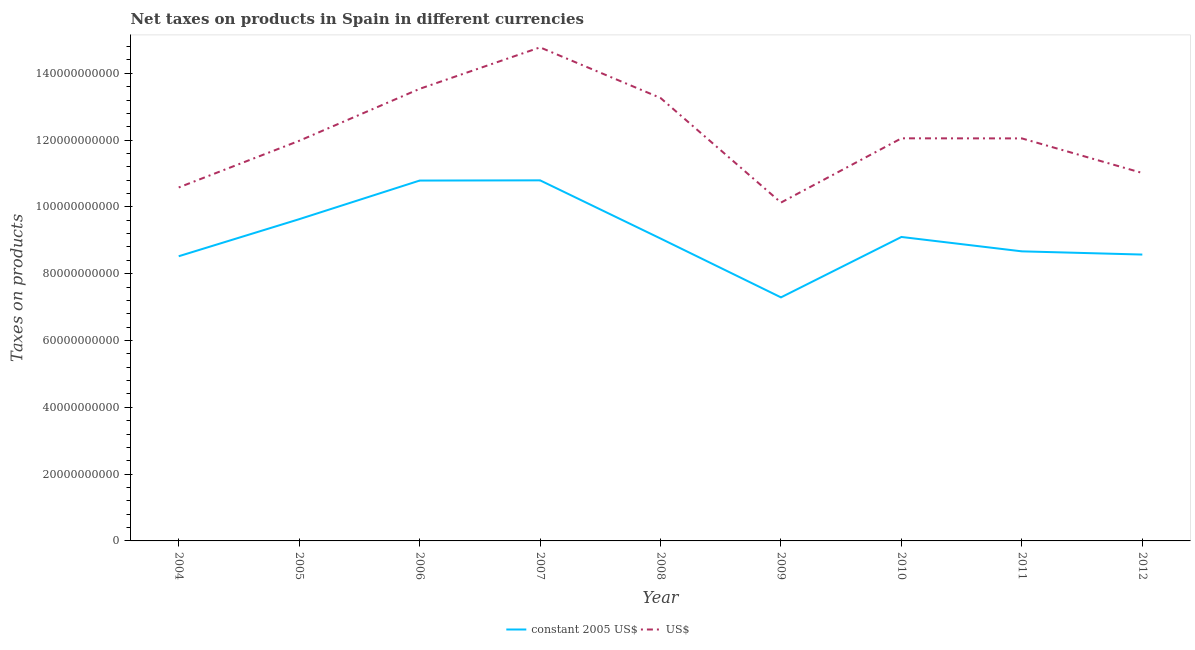Does the line corresponding to net taxes in us$ intersect with the line corresponding to net taxes in constant 2005 us$?
Your response must be concise. No. Is the number of lines equal to the number of legend labels?
Your answer should be compact. Yes. What is the net taxes in constant 2005 us$ in 2006?
Provide a succinct answer. 1.08e+11. Across all years, what is the maximum net taxes in us$?
Provide a short and direct response. 1.48e+11. Across all years, what is the minimum net taxes in constant 2005 us$?
Offer a very short reply. 7.29e+1. In which year was the net taxes in us$ maximum?
Your answer should be compact. 2007. What is the total net taxes in constant 2005 us$ in the graph?
Make the answer very short. 8.24e+11. What is the difference between the net taxes in us$ in 2005 and that in 2008?
Keep it short and to the point. -1.28e+1. What is the difference between the net taxes in constant 2005 us$ in 2011 and the net taxes in us$ in 2005?
Your answer should be very brief. -3.31e+1. What is the average net taxes in constant 2005 us$ per year?
Offer a terse response. 9.16e+1. In the year 2010, what is the difference between the net taxes in constant 2005 us$ and net taxes in us$?
Give a very brief answer. -2.95e+1. In how many years, is the net taxes in constant 2005 us$ greater than 124000000000 units?
Your response must be concise. 0. What is the ratio of the net taxes in us$ in 2008 to that in 2010?
Keep it short and to the point. 1.1. Is the net taxes in us$ in 2005 less than that in 2008?
Provide a short and direct response. Yes. Is the difference between the net taxes in constant 2005 us$ in 2004 and 2012 greater than the difference between the net taxes in us$ in 2004 and 2012?
Offer a very short reply. Yes. What is the difference between the highest and the second highest net taxes in us$?
Make the answer very short. 1.24e+1. What is the difference between the highest and the lowest net taxes in us$?
Give a very brief answer. 4.65e+1. Is the sum of the net taxes in us$ in 2004 and 2007 greater than the maximum net taxes in constant 2005 us$ across all years?
Keep it short and to the point. Yes. How many lines are there?
Provide a succinct answer. 2. How many years are there in the graph?
Offer a terse response. 9. What is the difference between two consecutive major ticks on the Y-axis?
Provide a short and direct response. 2.00e+1. Does the graph contain any zero values?
Keep it short and to the point. No. Does the graph contain grids?
Provide a succinct answer. No. Where does the legend appear in the graph?
Your answer should be compact. Bottom center. How many legend labels are there?
Your response must be concise. 2. What is the title of the graph?
Your response must be concise. Net taxes on products in Spain in different currencies. What is the label or title of the X-axis?
Make the answer very short. Year. What is the label or title of the Y-axis?
Give a very brief answer. Taxes on products. What is the Taxes on products in constant 2005 US$ in 2004?
Provide a short and direct response. 8.52e+1. What is the Taxes on products of US$ in 2004?
Ensure brevity in your answer.  1.06e+11. What is the Taxes on products of constant 2005 US$ in 2005?
Ensure brevity in your answer.  9.63e+1. What is the Taxes on products of US$ in 2005?
Give a very brief answer. 1.20e+11. What is the Taxes on products in constant 2005 US$ in 2006?
Keep it short and to the point. 1.08e+11. What is the Taxes on products in US$ in 2006?
Keep it short and to the point. 1.35e+11. What is the Taxes on products of constant 2005 US$ in 2007?
Give a very brief answer. 1.08e+11. What is the Taxes on products of US$ in 2007?
Make the answer very short. 1.48e+11. What is the Taxes on products in constant 2005 US$ in 2008?
Provide a short and direct response. 9.05e+1. What is the Taxes on products in US$ in 2008?
Your answer should be very brief. 1.33e+11. What is the Taxes on products of constant 2005 US$ in 2009?
Provide a succinct answer. 7.29e+1. What is the Taxes on products of US$ in 2009?
Provide a succinct answer. 1.01e+11. What is the Taxes on products of constant 2005 US$ in 2010?
Make the answer very short. 9.10e+1. What is the Taxes on products in US$ in 2010?
Ensure brevity in your answer.  1.21e+11. What is the Taxes on products in constant 2005 US$ in 2011?
Offer a very short reply. 8.67e+1. What is the Taxes on products in US$ in 2011?
Keep it short and to the point. 1.21e+11. What is the Taxes on products in constant 2005 US$ in 2012?
Your answer should be compact. 8.57e+1. What is the Taxes on products in US$ in 2012?
Provide a succinct answer. 1.10e+11. Across all years, what is the maximum Taxes on products in constant 2005 US$?
Offer a terse response. 1.08e+11. Across all years, what is the maximum Taxes on products in US$?
Ensure brevity in your answer.  1.48e+11. Across all years, what is the minimum Taxes on products of constant 2005 US$?
Keep it short and to the point. 7.29e+1. Across all years, what is the minimum Taxes on products of US$?
Provide a short and direct response. 1.01e+11. What is the total Taxes on products in constant 2005 US$ in the graph?
Your response must be concise. 8.24e+11. What is the total Taxes on products in US$ in the graph?
Provide a short and direct response. 1.09e+12. What is the difference between the Taxes on products of constant 2005 US$ in 2004 and that in 2005?
Keep it short and to the point. -1.11e+1. What is the difference between the Taxes on products of US$ in 2004 and that in 2005?
Provide a short and direct response. -1.40e+1. What is the difference between the Taxes on products of constant 2005 US$ in 2004 and that in 2006?
Give a very brief answer. -2.27e+1. What is the difference between the Taxes on products of US$ in 2004 and that in 2006?
Your answer should be very brief. -2.95e+1. What is the difference between the Taxes on products of constant 2005 US$ in 2004 and that in 2007?
Ensure brevity in your answer.  -2.27e+1. What is the difference between the Taxes on products in US$ in 2004 and that in 2007?
Provide a succinct answer. -4.19e+1. What is the difference between the Taxes on products in constant 2005 US$ in 2004 and that in 2008?
Your answer should be compact. -5.31e+09. What is the difference between the Taxes on products of US$ in 2004 and that in 2008?
Your answer should be compact. -2.68e+1. What is the difference between the Taxes on products of constant 2005 US$ in 2004 and that in 2009?
Ensure brevity in your answer.  1.23e+1. What is the difference between the Taxes on products of US$ in 2004 and that in 2009?
Make the answer very short. 4.52e+09. What is the difference between the Taxes on products in constant 2005 US$ in 2004 and that in 2010?
Your response must be concise. -5.77e+09. What is the difference between the Taxes on products of US$ in 2004 and that in 2010?
Keep it short and to the point. -1.47e+1. What is the difference between the Taxes on products of constant 2005 US$ in 2004 and that in 2011?
Give a very brief answer. -1.46e+09. What is the difference between the Taxes on products in US$ in 2004 and that in 2011?
Your answer should be very brief. -1.47e+1. What is the difference between the Taxes on products in constant 2005 US$ in 2004 and that in 2012?
Offer a terse response. -5.05e+08. What is the difference between the Taxes on products in US$ in 2004 and that in 2012?
Offer a very short reply. -4.33e+09. What is the difference between the Taxes on products of constant 2005 US$ in 2005 and that in 2006?
Your response must be concise. -1.16e+1. What is the difference between the Taxes on products in US$ in 2005 and that in 2006?
Provide a short and direct response. -1.56e+1. What is the difference between the Taxes on products in constant 2005 US$ in 2005 and that in 2007?
Keep it short and to the point. -1.16e+1. What is the difference between the Taxes on products of US$ in 2005 and that in 2007?
Your response must be concise. -2.80e+1. What is the difference between the Taxes on products of constant 2005 US$ in 2005 and that in 2008?
Make the answer very short. 5.78e+09. What is the difference between the Taxes on products in US$ in 2005 and that in 2008?
Offer a terse response. -1.28e+1. What is the difference between the Taxes on products of constant 2005 US$ in 2005 and that in 2009?
Keep it short and to the point. 2.34e+1. What is the difference between the Taxes on products of US$ in 2005 and that in 2009?
Your answer should be compact. 1.85e+1. What is the difference between the Taxes on products of constant 2005 US$ in 2005 and that in 2010?
Offer a terse response. 5.32e+09. What is the difference between the Taxes on products in US$ in 2005 and that in 2010?
Ensure brevity in your answer.  -7.45e+08. What is the difference between the Taxes on products of constant 2005 US$ in 2005 and that in 2011?
Make the answer very short. 9.63e+09. What is the difference between the Taxes on products of US$ in 2005 and that in 2011?
Give a very brief answer. -7.21e+08. What is the difference between the Taxes on products of constant 2005 US$ in 2005 and that in 2012?
Make the answer very short. 1.06e+1. What is the difference between the Taxes on products in US$ in 2005 and that in 2012?
Ensure brevity in your answer.  9.63e+09. What is the difference between the Taxes on products of constant 2005 US$ in 2006 and that in 2007?
Your response must be concise. -7.00e+07. What is the difference between the Taxes on products of US$ in 2006 and that in 2007?
Give a very brief answer. -1.24e+1. What is the difference between the Taxes on products in constant 2005 US$ in 2006 and that in 2008?
Offer a very short reply. 1.73e+1. What is the difference between the Taxes on products in US$ in 2006 and that in 2008?
Your answer should be very brief. 2.73e+09. What is the difference between the Taxes on products in constant 2005 US$ in 2006 and that in 2009?
Your answer should be very brief. 3.50e+1. What is the difference between the Taxes on products of US$ in 2006 and that in 2009?
Your answer should be very brief. 3.40e+1. What is the difference between the Taxes on products in constant 2005 US$ in 2006 and that in 2010?
Offer a terse response. 1.69e+1. What is the difference between the Taxes on products of US$ in 2006 and that in 2010?
Your answer should be very brief. 1.48e+1. What is the difference between the Taxes on products in constant 2005 US$ in 2006 and that in 2011?
Keep it short and to the point. 2.12e+1. What is the difference between the Taxes on products of US$ in 2006 and that in 2011?
Offer a terse response. 1.48e+1. What is the difference between the Taxes on products of constant 2005 US$ in 2006 and that in 2012?
Keep it short and to the point. 2.22e+1. What is the difference between the Taxes on products in US$ in 2006 and that in 2012?
Your response must be concise. 2.52e+1. What is the difference between the Taxes on products of constant 2005 US$ in 2007 and that in 2008?
Give a very brief answer. 1.74e+1. What is the difference between the Taxes on products in US$ in 2007 and that in 2008?
Give a very brief answer. 1.51e+1. What is the difference between the Taxes on products of constant 2005 US$ in 2007 and that in 2009?
Offer a very short reply. 3.50e+1. What is the difference between the Taxes on products in US$ in 2007 and that in 2009?
Offer a terse response. 4.65e+1. What is the difference between the Taxes on products in constant 2005 US$ in 2007 and that in 2010?
Your answer should be compact. 1.70e+1. What is the difference between the Taxes on products in US$ in 2007 and that in 2010?
Your answer should be very brief. 2.72e+1. What is the difference between the Taxes on products in constant 2005 US$ in 2007 and that in 2011?
Your answer should be compact. 2.13e+1. What is the difference between the Taxes on products of US$ in 2007 and that in 2011?
Make the answer very short. 2.73e+1. What is the difference between the Taxes on products in constant 2005 US$ in 2007 and that in 2012?
Your response must be concise. 2.22e+1. What is the difference between the Taxes on products in US$ in 2007 and that in 2012?
Your answer should be compact. 3.76e+1. What is the difference between the Taxes on products of constant 2005 US$ in 2008 and that in 2009?
Offer a very short reply. 1.76e+1. What is the difference between the Taxes on products of US$ in 2008 and that in 2009?
Your answer should be very brief. 3.13e+1. What is the difference between the Taxes on products of constant 2005 US$ in 2008 and that in 2010?
Your answer should be compact. -4.65e+08. What is the difference between the Taxes on products of US$ in 2008 and that in 2010?
Ensure brevity in your answer.  1.21e+1. What is the difference between the Taxes on products of constant 2005 US$ in 2008 and that in 2011?
Give a very brief answer. 3.84e+09. What is the difference between the Taxes on products of US$ in 2008 and that in 2011?
Make the answer very short. 1.21e+1. What is the difference between the Taxes on products of constant 2005 US$ in 2008 and that in 2012?
Your answer should be compact. 4.80e+09. What is the difference between the Taxes on products of US$ in 2008 and that in 2012?
Your answer should be compact. 2.25e+1. What is the difference between the Taxes on products of constant 2005 US$ in 2009 and that in 2010?
Your answer should be compact. -1.81e+1. What is the difference between the Taxes on products of US$ in 2009 and that in 2010?
Your response must be concise. -1.92e+1. What is the difference between the Taxes on products in constant 2005 US$ in 2009 and that in 2011?
Your response must be concise. -1.38e+1. What is the difference between the Taxes on products of US$ in 2009 and that in 2011?
Give a very brief answer. -1.92e+1. What is the difference between the Taxes on products in constant 2005 US$ in 2009 and that in 2012?
Provide a short and direct response. -1.28e+1. What is the difference between the Taxes on products of US$ in 2009 and that in 2012?
Make the answer very short. -8.86e+09. What is the difference between the Taxes on products of constant 2005 US$ in 2010 and that in 2011?
Your answer should be compact. 4.31e+09. What is the difference between the Taxes on products of US$ in 2010 and that in 2011?
Your answer should be compact. 2.38e+07. What is the difference between the Taxes on products of constant 2005 US$ in 2010 and that in 2012?
Offer a very short reply. 5.27e+09. What is the difference between the Taxes on products of US$ in 2010 and that in 2012?
Ensure brevity in your answer.  1.04e+1. What is the difference between the Taxes on products in constant 2005 US$ in 2011 and that in 2012?
Give a very brief answer. 9.60e+08. What is the difference between the Taxes on products of US$ in 2011 and that in 2012?
Your answer should be very brief. 1.04e+1. What is the difference between the Taxes on products of constant 2005 US$ in 2004 and the Taxes on products of US$ in 2005?
Your response must be concise. -3.46e+1. What is the difference between the Taxes on products of constant 2005 US$ in 2004 and the Taxes on products of US$ in 2006?
Ensure brevity in your answer.  -5.01e+1. What is the difference between the Taxes on products of constant 2005 US$ in 2004 and the Taxes on products of US$ in 2007?
Your answer should be very brief. -6.25e+1. What is the difference between the Taxes on products in constant 2005 US$ in 2004 and the Taxes on products in US$ in 2008?
Your answer should be compact. -4.74e+1. What is the difference between the Taxes on products in constant 2005 US$ in 2004 and the Taxes on products in US$ in 2009?
Your answer should be compact. -1.61e+1. What is the difference between the Taxes on products in constant 2005 US$ in 2004 and the Taxes on products in US$ in 2010?
Provide a succinct answer. -3.53e+1. What is the difference between the Taxes on products in constant 2005 US$ in 2004 and the Taxes on products in US$ in 2011?
Your response must be concise. -3.53e+1. What is the difference between the Taxes on products in constant 2005 US$ in 2004 and the Taxes on products in US$ in 2012?
Your response must be concise. -2.49e+1. What is the difference between the Taxes on products in constant 2005 US$ in 2005 and the Taxes on products in US$ in 2006?
Make the answer very short. -3.90e+1. What is the difference between the Taxes on products of constant 2005 US$ in 2005 and the Taxes on products of US$ in 2007?
Offer a terse response. -5.14e+1. What is the difference between the Taxes on products in constant 2005 US$ in 2005 and the Taxes on products in US$ in 2008?
Make the answer very short. -3.63e+1. What is the difference between the Taxes on products of constant 2005 US$ in 2005 and the Taxes on products of US$ in 2009?
Keep it short and to the point. -4.98e+09. What is the difference between the Taxes on products in constant 2005 US$ in 2005 and the Taxes on products in US$ in 2010?
Keep it short and to the point. -2.42e+1. What is the difference between the Taxes on products of constant 2005 US$ in 2005 and the Taxes on products of US$ in 2011?
Your response must be concise. -2.42e+1. What is the difference between the Taxes on products of constant 2005 US$ in 2005 and the Taxes on products of US$ in 2012?
Make the answer very short. -1.38e+1. What is the difference between the Taxes on products in constant 2005 US$ in 2006 and the Taxes on products in US$ in 2007?
Offer a very short reply. -3.99e+1. What is the difference between the Taxes on products of constant 2005 US$ in 2006 and the Taxes on products of US$ in 2008?
Give a very brief answer. -2.47e+1. What is the difference between the Taxes on products in constant 2005 US$ in 2006 and the Taxes on products in US$ in 2009?
Offer a terse response. 6.59e+09. What is the difference between the Taxes on products in constant 2005 US$ in 2006 and the Taxes on products in US$ in 2010?
Provide a succinct answer. -1.26e+1. What is the difference between the Taxes on products in constant 2005 US$ in 2006 and the Taxes on products in US$ in 2011?
Your answer should be very brief. -1.26e+1. What is the difference between the Taxes on products in constant 2005 US$ in 2006 and the Taxes on products in US$ in 2012?
Ensure brevity in your answer.  -2.27e+09. What is the difference between the Taxes on products in constant 2005 US$ in 2007 and the Taxes on products in US$ in 2008?
Your response must be concise. -2.47e+1. What is the difference between the Taxes on products in constant 2005 US$ in 2007 and the Taxes on products in US$ in 2009?
Offer a very short reply. 6.66e+09. What is the difference between the Taxes on products in constant 2005 US$ in 2007 and the Taxes on products in US$ in 2010?
Offer a terse response. -1.26e+1. What is the difference between the Taxes on products of constant 2005 US$ in 2007 and the Taxes on products of US$ in 2011?
Give a very brief answer. -1.26e+1. What is the difference between the Taxes on products of constant 2005 US$ in 2007 and the Taxes on products of US$ in 2012?
Your answer should be very brief. -2.20e+09. What is the difference between the Taxes on products in constant 2005 US$ in 2008 and the Taxes on products in US$ in 2009?
Make the answer very short. -1.08e+1. What is the difference between the Taxes on products of constant 2005 US$ in 2008 and the Taxes on products of US$ in 2010?
Make the answer very short. -3.00e+1. What is the difference between the Taxes on products of constant 2005 US$ in 2008 and the Taxes on products of US$ in 2011?
Provide a succinct answer. -3.00e+1. What is the difference between the Taxes on products of constant 2005 US$ in 2008 and the Taxes on products of US$ in 2012?
Your answer should be very brief. -1.96e+1. What is the difference between the Taxes on products in constant 2005 US$ in 2009 and the Taxes on products in US$ in 2010?
Offer a terse response. -4.76e+1. What is the difference between the Taxes on products in constant 2005 US$ in 2009 and the Taxes on products in US$ in 2011?
Offer a terse response. -4.76e+1. What is the difference between the Taxes on products of constant 2005 US$ in 2009 and the Taxes on products of US$ in 2012?
Provide a short and direct response. -3.72e+1. What is the difference between the Taxes on products of constant 2005 US$ in 2010 and the Taxes on products of US$ in 2011?
Offer a terse response. -2.95e+1. What is the difference between the Taxes on products of constant 2005 US$ in 2010 and the Taxes on products of US$ in 2012?
Ensure brevity in your answer.  -1.92e+1. What is the difference between the Taxes on products in constant 2005 US$ in 2011 and the Taxes on products in US$ in 2012?
Provide a succinct answer. -2.35e+1. What is the average Taxes on products of constant 2005 US$ per year?
Provide a short and direct response. 9.16e+1. What is the average Taxes on products in US$ per year?
Your answer should be compact. 1.22e+11. In the year 2004, what is the difference between the Taxes on products in constant 2005 US$ and Taxes on products in US$?
Provide a succinct answer. -2.06e+1. In the year 2005, what is the difference between the Taxes on products in constant 2005 US$ and Taxes on products in US$?
Your answer should be compact. -2.35e+1. In the year 2006, what is the difference between the Taxes on products in constant 2005 US$ and Taxes on products in US$?
Your answer should be compact. -2.75e+1. In the year 2007, what is the difference between the Taxes on products of constant 2005 US$ and Taxes on products of US$?
Make the answer very short. -3.98e+1. In the year 2008, what is the difference between the Taxes on products in constant 2005 US$ and Taxes on products in US$?
Your answer should be very brief. -4.21e+1. In the year 2009, what is the difference between the Taxes on products of constant 2005 US$ and Taxes on products of US$?
Your response must be concise. -2.84e+1. In the year 2010, what is the difference between the Taxes on products in constant 2005 US$ and Taxes on products in US$?
Your answer should be compact. -2.95e+1. In the year 2011, what is the difference between the Taxes on products in constant 2005 US$ and Taxes on products in US$?
Your response must be concise. -3.38e+1. In the year 2012, what is the difference between the Taxes on products in constant 2005 US$ and Taxes on products in US$?
Offer a terse response. -2.44e+1. What is the ratio of the Taxes on products in constant 2005 US$ in 2004 to that in 2005?
Give a very brief answer. 0.88. What is the ratio of the Taxes on products in US$ in 2004 to that in 2005?
Offer a terse response. 0.88. What is the ratio of the Taxes on products in constant 2005 US$ in 2004 to that in 2006?
Your answer should be compact. 0.79. What is the ratio of the Taxes on products in US$ in 2004 to that in 2006?
Your response must be concise. 0.78. What is the ratio of the Taxes on products in constant 2005 US$ in 2004 to that in 2007?
Your response must be concise. 0.79. What is the ratio of the Taxes on products in US$ in 2004 to that in 2007?
Provide a short and direct response. 0.72. What is the ratio of the Taxes on products in constant 2005 US$ in 2004 to that in 2008?
Your answer should be very brief. 0.94. What is the ratio of the Taxes on products in US$ in 2004 to that in 2008?
Offer a terse response. 0.8. What is the ratio of the Taxes on products in constant 2005 US$ in 2004 to that in 2009?
Offer a very short reply. 1.17. What is the ratio of the Taxes on products of US$ in 2004 to that in 2009?
Make the answer very short. 1.04. What is the ratio of the Taxes on products of constant 2005 US$ in 2004 to that in 2010?
Offer a very short reply. 0.94. What is the ratio of the Taxes on products of US$ in 2004 to that in 2010?
Ensure brevity in your answer.  0.88. What is the ratio of the Taxes on products in constant 2005 US$ in 2004 to that in 2011?
Provide a succinct answer. 0.98. What is the ratio of the Taxes on products in US$ in 2004 to that in 2011?
Offer a very short reply. 0.88. What is the ratio of the Taxes on products of constant 2005 US$ in 2004 to that in 2012?
Offer a very short reply. 0.99. What is the ratio of the Taxes on products of US$ in 2004 to that in 2012?
Give a very brief answer. 0.96. What is the ratio of the Taxes on products in constant 2005 US$ in 2005 to that in 2006?
Offer a very short reply. 0.89. What is the ratio of the Taxes on products of US$ in 2005 to that in 2006?
Keep it short and to the point. 0.89. What is the ratio of the Taxes on products in constant 2005 US$ in 2005 to that in 2007?
Ensure brevity in your answer.  0.89. What is the ratio of the Taxes on products of US$ in 2005 to that in 2007?
Make the answer very short. 0.81. What is the ratio of the Taxes on products in constant 2005 US$ in 2005 to that in 2008?
Offer a very short reply. 1.06. What is the ratio of the Taxes on products in US$ in 2005 to that in 2008?
Your response must be concise. 0.9. What is the ratio of the Taxes on products of constant 2005 US$ in 2005 to that in 2009?
Your answer should be very brief. 1.32. What is the ratio of the Taxes on products in US$ in 2005 to that in 2009?
Your response must be concise. 1.18. What is the ratio of the Taxes on products in constant 2005 US$ in 2005 to that in 2010?
Ensure brevity in your answer.  1.06. What is the ratio of the Taxes on products in constant 2005 US$ in 2005 to that in 2011?
Your answer should be very brief. 1.11. What is the ratio of the Taxes on products in US$ in 2005 to that in 2011?
Your response must be concise. 0.99. What is the ratio of the Taxes on products in constant 2005 US$ in 2005 to that in 2012?
Your answer should be very brief. 1.12. What is the ratio of the Taxes on products of US$ in 2005 to that in 2012?
Offer a terse response. 1.09. What is the ratio of the Taxes on products of constant 2005 US$ in 2006 to that in 2007?
Your answer should be compact. 1. What is the ratio of the Taxes on products of US$ in 2006 to that in 2007?
Give a very brief answer. 0.92. What is the ratio of the Taxes on products of constant 2005 US$ in 2006 to that in 2008?
Your answer should be very brief. 1.19. What is the ratio of the Taxes on products in US$ in 2006 to that in 2008?
Make the answer very short. 1.02. What is the ratio of the Taxes on products in constant 2005 US$ in 2006 to that in 2009?
Offer a terse response. 1.48. What is the ratio of the Taxes on products of US$ in 2006 to that in 2009?
Keep it short and to the point. 1.34. What is the ratio of the Taxes on products in constant 2005 US$ in 2006 to that in 2010?
Keep it short and to the point. 1.19. What is the ratio of the Taxes on products of US$ in 2006 to that in 2010?
Your response must be concise. 1.12. What is the ratio of the Taxes on products of constant 2005 US$ in 2006 to that in 2011?
Your response must be concise. 1.24. What is the ratio of the Taxes on products in US$ in 2006 to that in 2011?
Ensure brevity in your answer.  1.12. What is the ratio of the Taxes on products of constant 2005 US$ in 2006 to that in 2012?
Keep it short and to the point. 1.26. What is the ratio of the Taxes on products in US$ in 2006 to that in 2012?
Give a very brief answer. 1.23. What is the ratio of the Taxes on products in constant 2005 US$ in 2007 to that in 2008?
Offer a terse response. 1.19. What is the ratio of the Taxes on products of US$ in 2007 to that in 2008?
Your response must be concise. 1.11. What is the ratio of the Taxes on products of constant 2005 US$ in 2007 to that in 2009?
Your response must be concise. 1.48. What is the ratio of the Taxes on products of US$ in 2007 to that in 2009?
Ensure brevity in your answer.  1.46. What is the ratio of the Taxes on products of constant 2005 US$ in 2007 to that in 2010?
Ensure brevity in your answer.  1.19. What is the ratio of the Taxes on products of US$ in 2007 to that in 2010?
Provide a short and direct response. 1.23. What is the ratio of the Taxes on products in constant 2005 US$ in 2007 to that in 2011?
Give a very brief answer. 1.25. What is the ratio of the Taxes on products in US$ in 2007 to that in 2011?
Keep it short and to the point. 1.23. What is the ratio of the Taxes on products in constant 2005 US$ in 2007 to that in 2012?
Keep it short and to the point. 1.26. What is the ratio of the Taxes on products of US$ in 2007 to that in 2012?
Offer a very short reply. 1.34. What is the ratio of the Taxes on products in constant 2005 US$ in 2008 to that in 2009?
Give a very brief answer. 1.24. What is the ratio of the Taxes on products of US$ in 2008 to that in 2009?
Offer a terse response. 1.31. What is the ratio of the Taxes on products of constant 2005 US$ in 2008 to that in 2010?
Your answer should be very brief. 0.99. What is the ratio of the Taxes on products in US$ in 2008 to that in 2010?
Offer a very short reply. 1.1. What is the ratio of the Taxes on products of constant 2005 US$ in 2008 to that in 2011?
Make the answer very short. 1.04. What is the ratio of the Taxes on products of US$ in 2008 to that in 2011?
Offer a very short reply. 1.1. What is the ratio of the Taxes on products of constant 2005 US$ in 2008 to that in 2012?
Your response must be concise. 1.06. What is the ratio of the Taxes on products of US$ in 2008 to that in 2012?
Make the answer very short. 1.2. What is the ratio of the Taxes on products in constant 2005 US$ in 2009 to that in 2010?
Your answer should be very brief. 0.8. What is the ratio of the Taxes on products of US$ in 2009 to that in 2010?
Keep it short and to the point. 0.84. What is the ratio of the Taxes on products of constant 2005 US$ in 2009 to that in 2011?
Your response must be concise. 0.84. What is the ratio of the Taxes on products of US$ in 2009 to that in 2011?
Provide a succinct answer. 0.84. What is the ratio of the Taxes on products of constant 2005 US$ in 2009 to that in 2012?
Provide a succinct answer. 0.85. What is the ratio of the Taxes on products in US$ in 2009 to that in 2012?
Keep it short and to the point. 0.92. What is the ratio of the Taxes on products in constant 2005 US$ in 2010 to that in 2011?
Provide a succinct answer. 1.05. What is the ratio of the Taxes on products of constant 2005 US$ in 2010 to that in 2012?
Your answer should be compact. 1.06. What is the ratio of the Taxes on products in US$ in 2010 to that in 2012?
Provide a short and direct response. 1.09. What is the ratio of the Taxes on products in constant 2005 US$ in 2011 to that in 2012?
Your answer should be compact. 1.01. What is the ratio of the Taxes on products of US$ in 2011 to that in 2012?
Offer a very short reply. 1.09. What is the difference between the highest and the second highest Taxes on products in constant 2005 US$?
Keep it short and to the point. 7.00e+07. What is the difference between the highest and the second highest Taxes on products in US$?
Offer a very short reply. 1.24e+1. What is the difference between the highest and the lowest Taxes on products in constant 2005 US$?
Your answer should be compact. 3.50e+1. What is the difference between the highest and the lowest Taxes on products of US$?
Your answer should be very brief. 4.65e+1. 